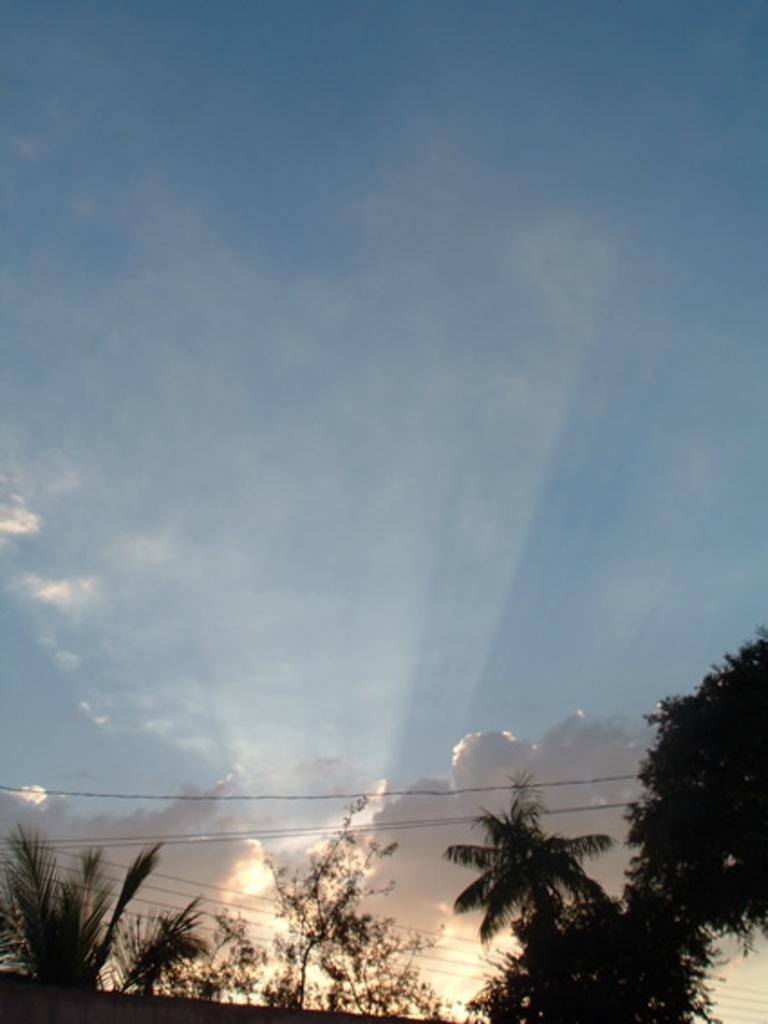Where was the image taken? The image was clicked outside the city. What can be seen in the foreground of the image? There are trees in the foreground of the image. What can be seen in the background of the image? There are cables and the sky visible in the background of the image. What is the condition of the sky in the image? Clouds are present in the sky. How many rabbits are hiding under the quilt in the image? There are no rabbits or quilts present in the image. 